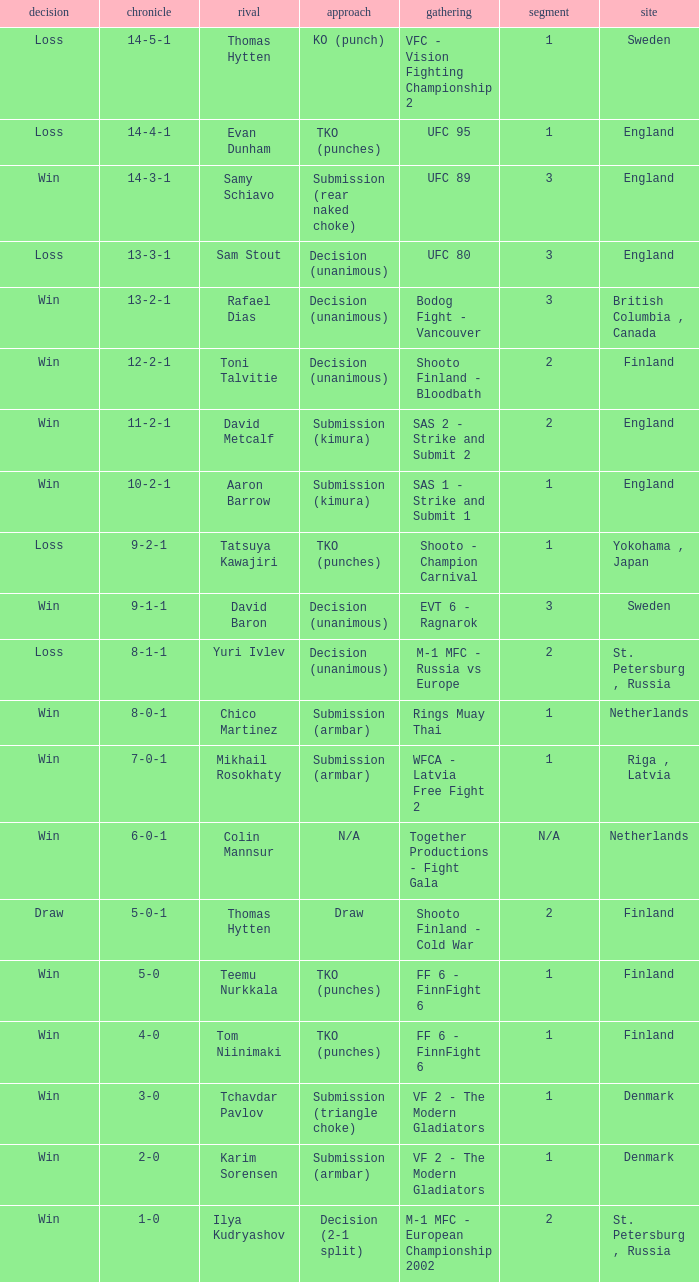What's the location when the record was 6-0-1? Netherlands. 